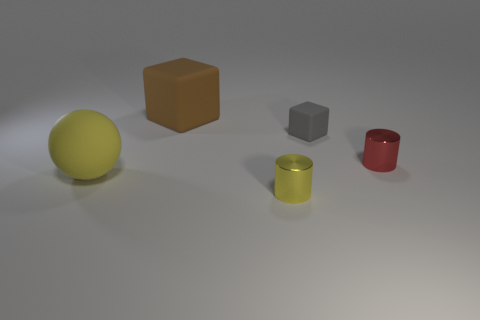There is a metallic object that is in front of the yellow matte sphere; what color is it?
Keep it short and to the point. Yellow. Are there fewer large brown cubes on the right side of the yellow cylinder than tiny metal objects?
Provide a short and direct response. Yes. What size is the metallic thing that is the same color as the large rubber ball?
Make the answer very short. Small. Is the material of the tiny red cylinder the same as the gray thing?
Offer a terse response. No. What number of things are either cubes in front of the large brown cube or rubber things on the left side of the gray matte block?
Provide a short and direct response. 3. Is there a gray rubber block of the same size as the red cylinder?
Keep it short and to the point. Yes. There is another large object that is the same shape as the gray matte thing; what color is it?
Make the answer very short. Brown. Are there any small gray rubber objects left of the large matte thing that is behind the big yellow matte thing?
Offer a terse response. No. Do the metal object that is in front of the big yellow matte object and the gray thing have the same shape?
Offer a terse response. No. The yellow rubber thing is what shape?
Offer a very short reply. Sphere. 